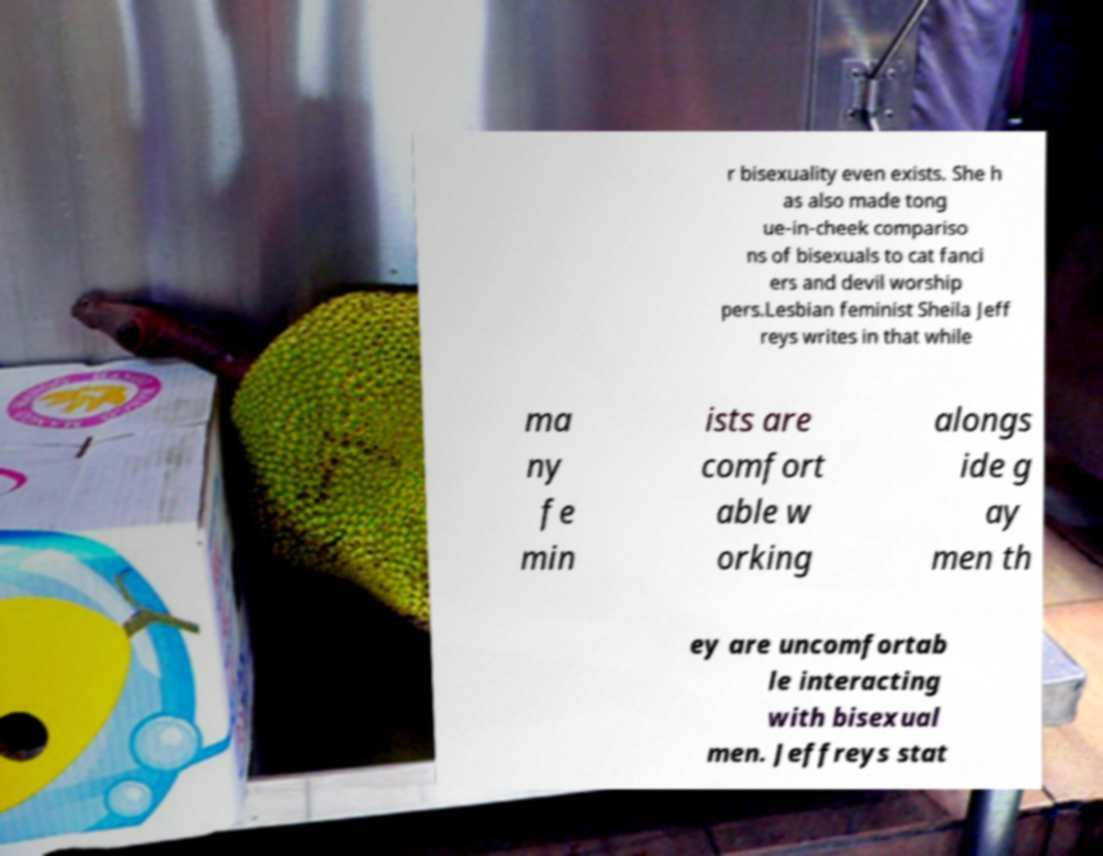For documentation purposes, I need the text within this image transcribed. Could you provide that? r bisexuality even exists. She h as also made tong ue-in-cheek compariso ns of bisexuals to cat fanci ers and devil worship pers.Lesbian feminist Sheila Jeff reys writes in that while ma ny fe min ists are comfort able w orking alongs ide g ay men th ey are uncomfortab le interacting with bisexual men. Jeffreys stat 